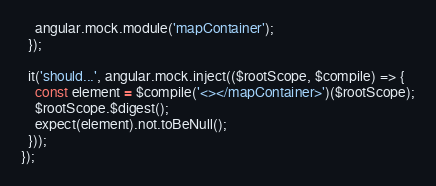<code> <loc_0><loc_0><loc_500><loc_500><_JavaScript_>    angular.mock.module('mapContainer');
  });

  it('should...', angular.mock.inject(($rootScope, $compile) => {
    const element = $compile('<></mapContainer>')($rootScope);
    $rootScope.$digest();
    expect(element).not.toBeNull();
  }));
});
</code> 